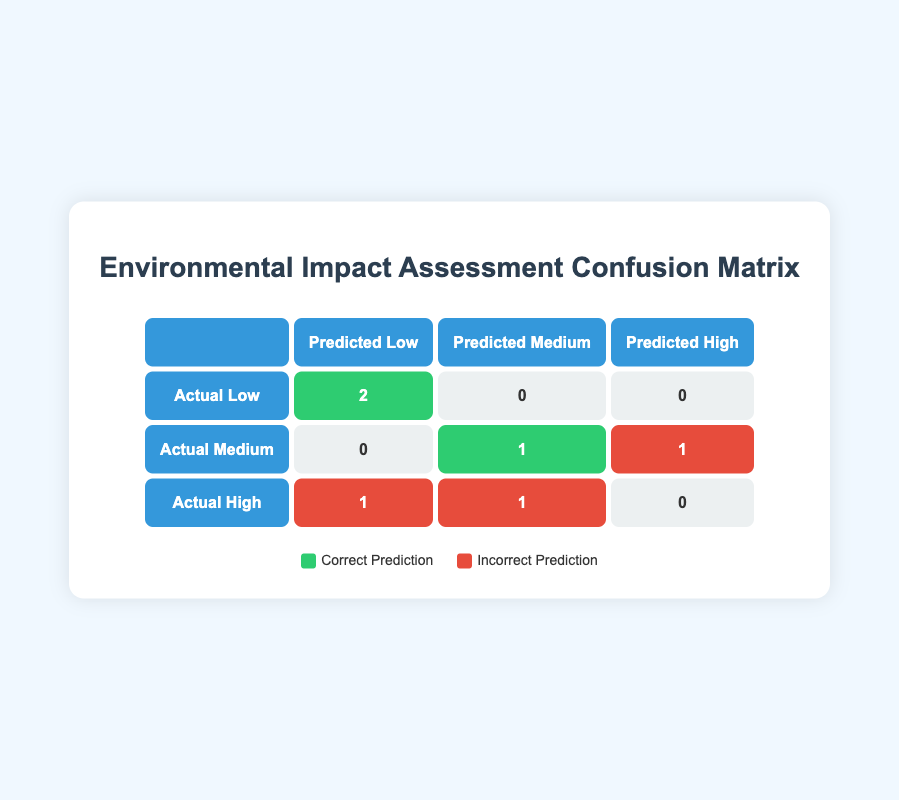What is the total number of correct predictions? The table shows two correct predictions in the "Actual Low" row and one correct prediction in the "Actual Medium" row, adding up to a total of 3 correct predictions.
Answer: 3 How many projects were predicted to have low impact? There are 2 projects listed in the "Predicted Low" column: "Riverfront Residential Complex" and "Harborview Luxury Condos."
Answer: 2 What is the difference between correct and incorrect predictions for actual medium impact? The table indicates that there is 1 correct prediction (for "Eastside Mixed-Use Development") and 1 incorrect prediction (for "Greenfield Industrial Park") for the actual medium impact, resulting in a difference of 0.
Answer: 0 Is it true that there were more incorrect predictions than correct ones in total? There are 3 correct predictions and 3 incorrect predictions in the table, so it is not true that there were more incorrect predictions than correct ones; they are equal.
Answer: No What is the total count of projects with an actual impact of high? The "Actual High" row shows that there is 1 project that had a predicted low impact and 1 that had a predicted medium impact, leading to a total of 2 projects with an actual impact of high.
Answer: 2 How many projects had a correct prediction of low impact? The table lists 2 correct predictions of low impact under the "Actual Low" row, corresponding to the "Riverfront Residential Complex" and "Harborview Luxury Condos."
Answer: 2 What is the prediction accuracy for projects with actual high impact? There are 2 incorrect predictions in the "Actual High" row out of a total of 2 projects (1 incorrectly predicted low and 1 incorrectly predicted medium), leading to an accuracy of 0%.
Answer: 0% How many projects were predicted to have medium impact but had a high actual impact? Looking at the table, there is 1 project that was predicted to have medium impact but had a high actual impact (the "Central City Shopping Mall").
Answer: 1 